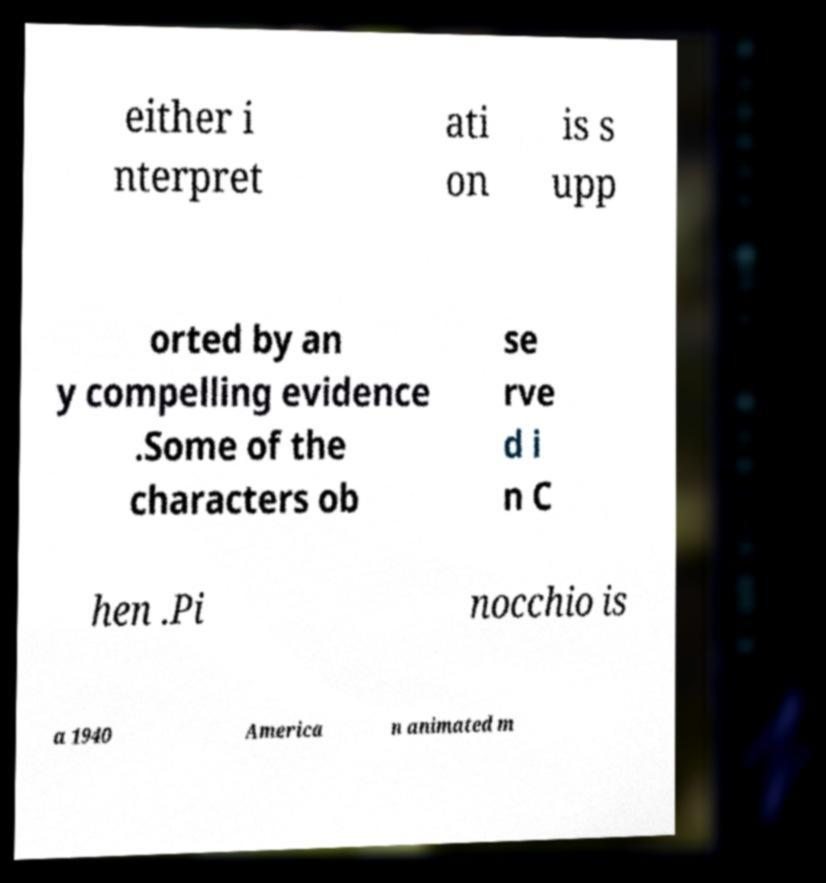Can you accurately transcribe the text from the provided image for me? either i nterpret ati on is s upp orted by an y compelling evidence .Some of the characters ob se rve d i n C hen .Pi nocchio is a 1940 America n animated m 